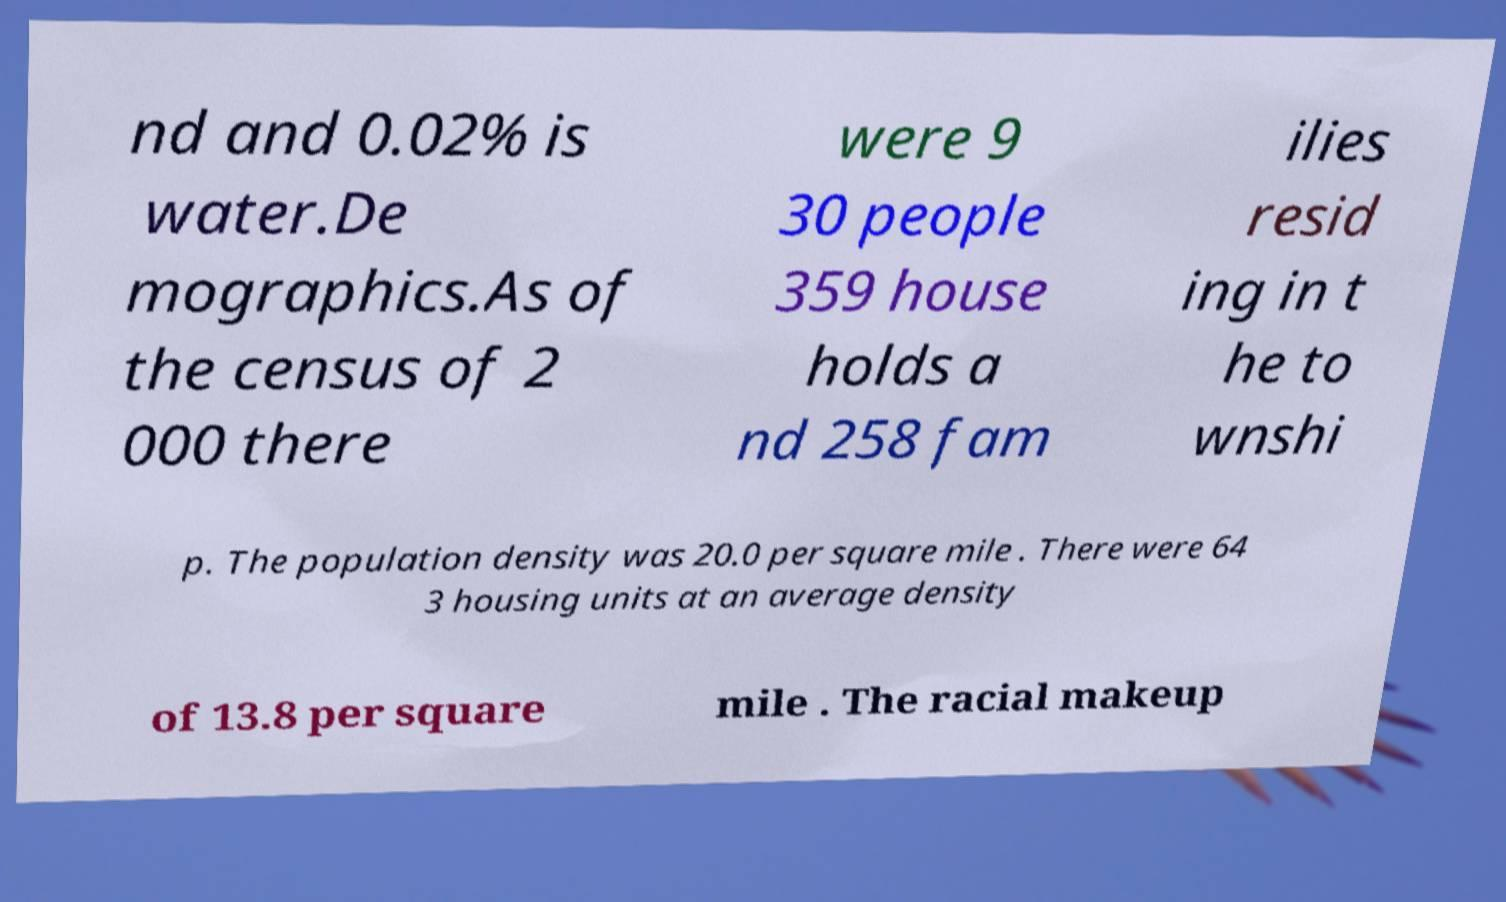Could you extract and type out the text from this image? nd and 0.02% is water.De mographics.As of the census of 2 000 there were 9 30 people 359 house holds a nd 258 fam ilies resid ing in t he to wnshi p. The population density was 20.0 per square mile . There were 64 3 housing units at an average density of 13.8 per square mile . The racial makeup 